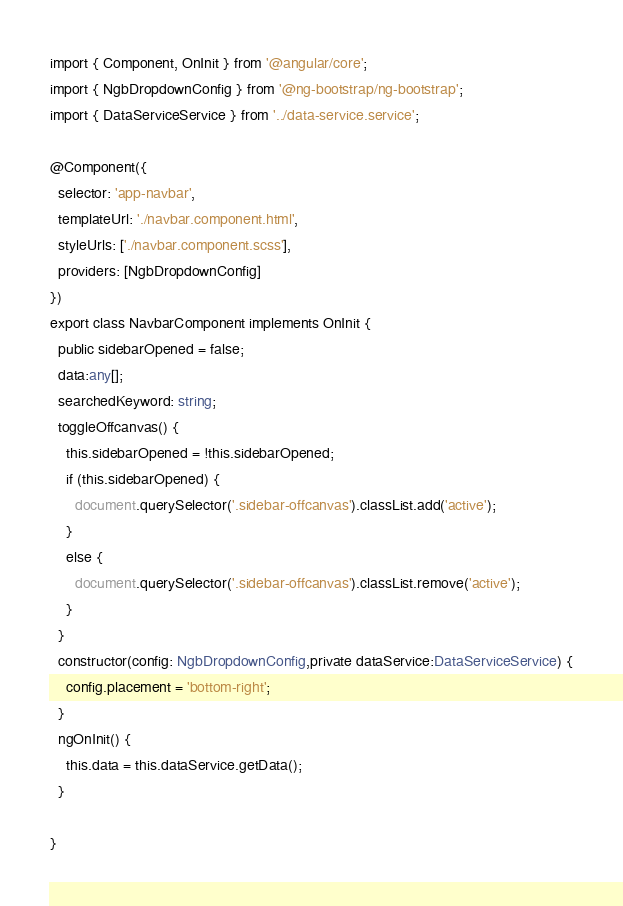Convert code to text. <code><loc_0><loc_0><loc_500><loc_500><_TypeScript_>import { Component, OnInit } from '@angular/core';
import { NgbDropdownConfig } from '@ng-bootstrap/ng-bootstrap';
import { DataServiceService } from '../data-service.service';

@Component({
  selector: 'app-navbar',
  templateUrl: './navbar.component.html',
  styleUrls: ['./navbar.component.scss'],
  providers: [NgbDropdownConfig]
})
export class NavbarComponent implements OnInit {
  public sidebarOpened = false;
  data:any[];
  searchedKeyword: string;
  toggleOffcanvas() {
    this.sidebarOpened = !this.sidebarOpened;
    if (this.sidebarOpened) {
      document.querySelector('.sidebar-offcanvas').classList.add('active');
    }
    else {
      document.querySelector('.sidebar-offcanvas').classList.remove('active');
    }
  }
  constructor(config: NgbDropdownConfig,private dataService:DataServiceService) {
    config.placement = 'bottom-right';
  }
  ngOnInit() {
    this.data = this.dataService.getData();
  }

}
</code> 